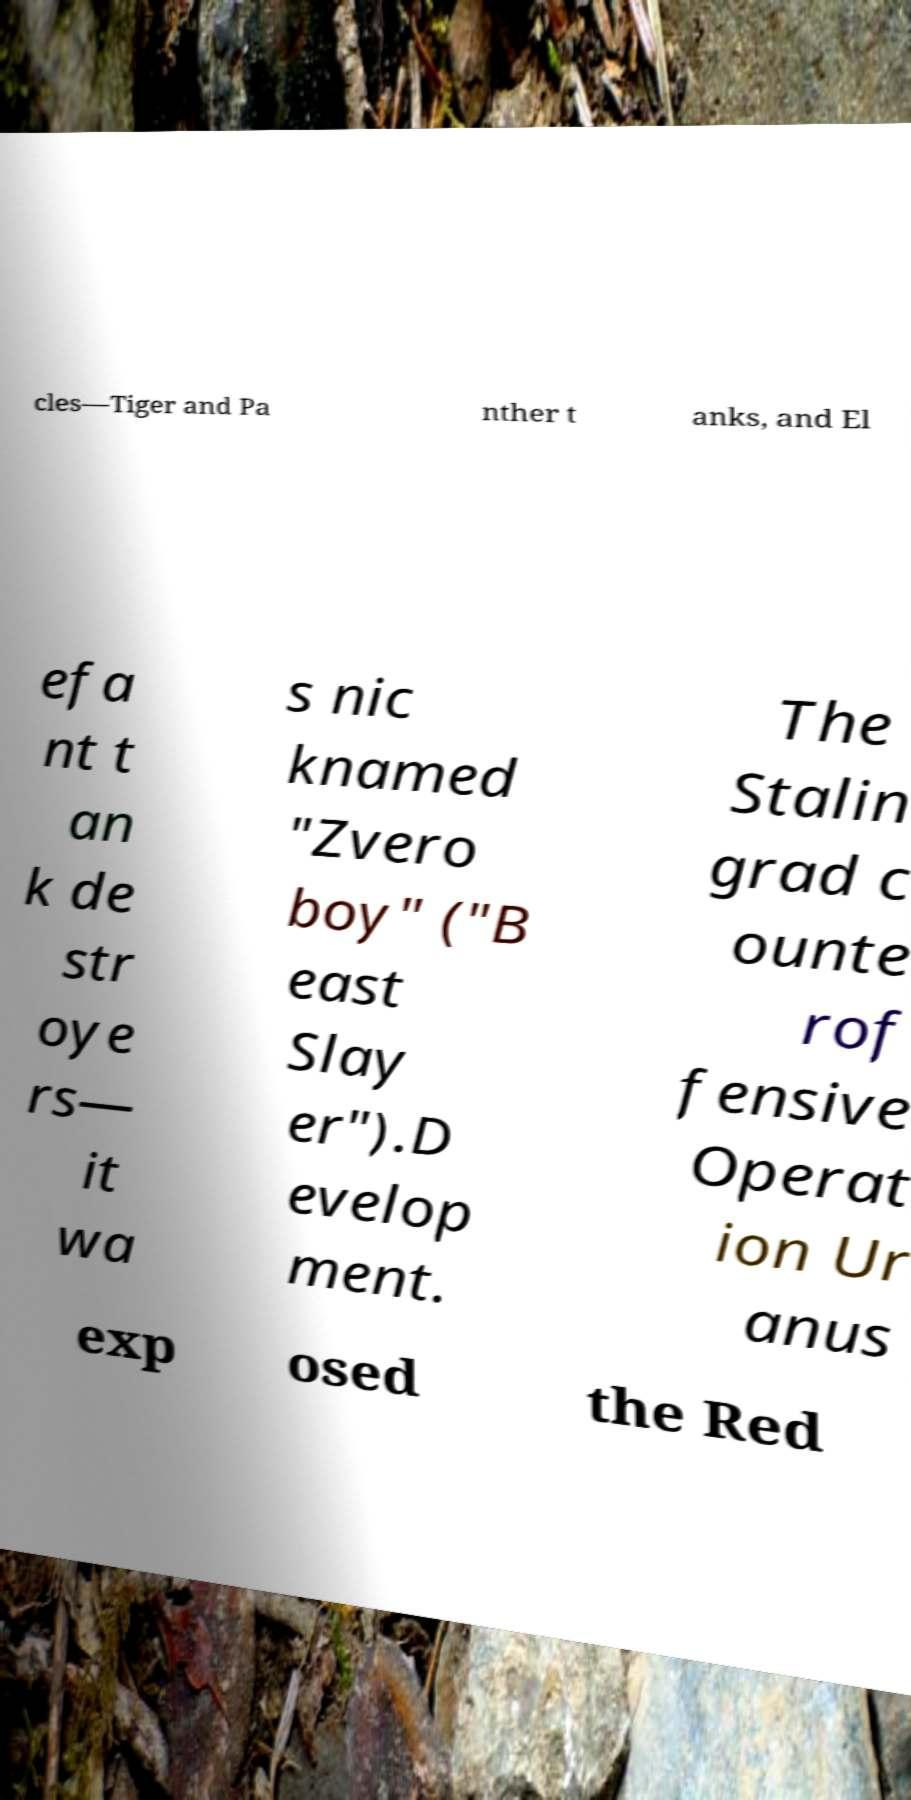Please identify and transcribe the text found in this image. cles—Tiger and Pa nther t anks, and El efa nt t an k de str oye rs— it wa s nic knamed "Zvero boy" ("B east Slay er").D evelop ment. The Stalin grad c ounte rof fensive Operat ion Ur anus exp osed the Red 